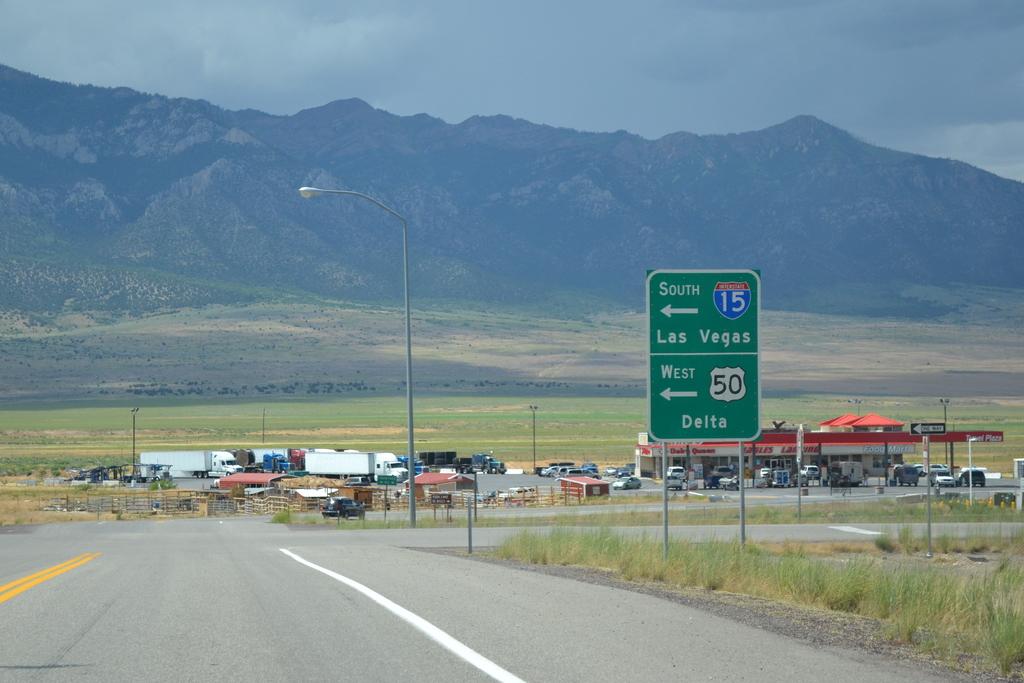Which city would you reach traveling west?
Provide a short and direct response. Delta. 